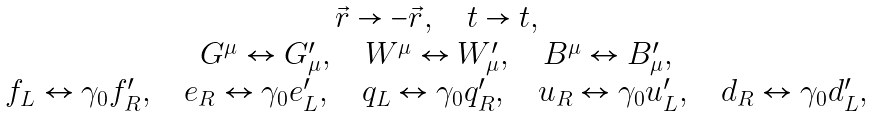Convert formula to latex. <formula><loc_0><loc_0><loc_500><loc_500>\begin{array} { c } \vec { r } \rightarrow - \vec { r } , \quad t \rightarrow t , \\ G ^ { \mu } \leftrightarrow G ^ { \prime } _ { \mu } , \quad W ^ { \mu } \leftrightarrow W ^ { \prime } _ { \mu } , \quad B ^ { \mu } \leftrightarrow B ^ { \prime } _ { \mu } , \\ f _ { L } \leftrightarrow \gamma _ { 0 } f ^ { \prime } _ { R } , \quad e _ { R } \leftrightarrow \gamma _ { 0 } e ^ { \prime } _ { L } , \quad q _ { L } \leftrightarrow \gamma _ { 0 } q ^ { \prime } _ { R } , \quad u _ { R } \leftrightarrow \gamma _ { 0 } u ^ { \prime } _ { L } , \quad d _ { R } \leftrightarrow \gamma _ { 0 } d ^ { \prime } _ { L } , \end{array}</formula> 